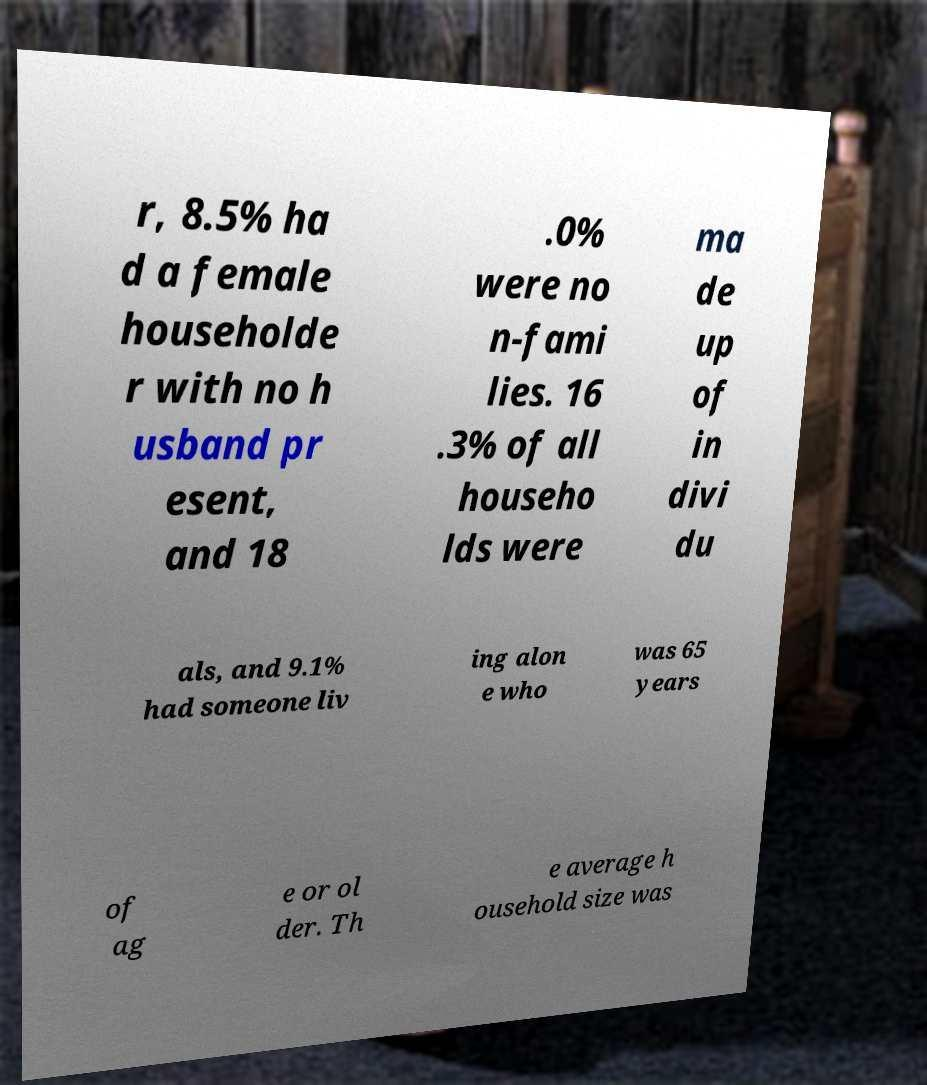Can you accurately transcribe the text from the provided image for me? r, 8.5% ha d a female householde r with no h usband pr esent, and 18 .0% were no n-fami lies. 16 .3% of all househo lds were ma de up of in divi du als, and 9.1% had someone liv ing alon e who was 65 years of ag e or ol der. Th e average h ousehold size was 